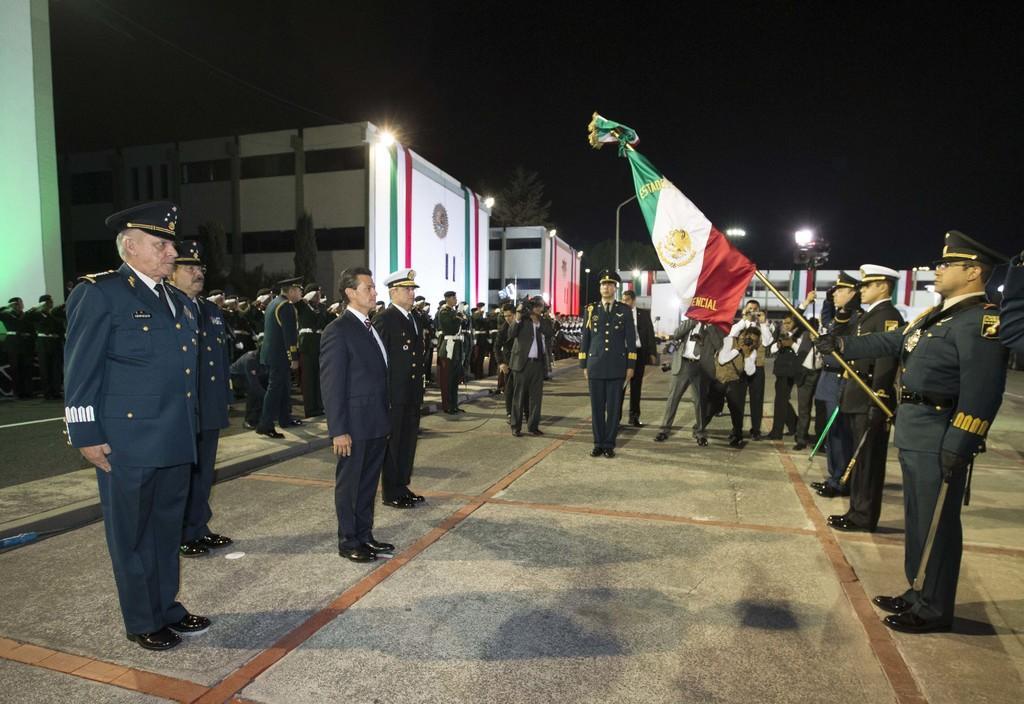Can you describe this image briefly? In this image there are people standing on the road. There is a person holding a pole which is having a flag. There are people wearing uniforms and caps. There are few people holding the cameras. There are street lights. Background there are buildings. Top of the image there is sky. 